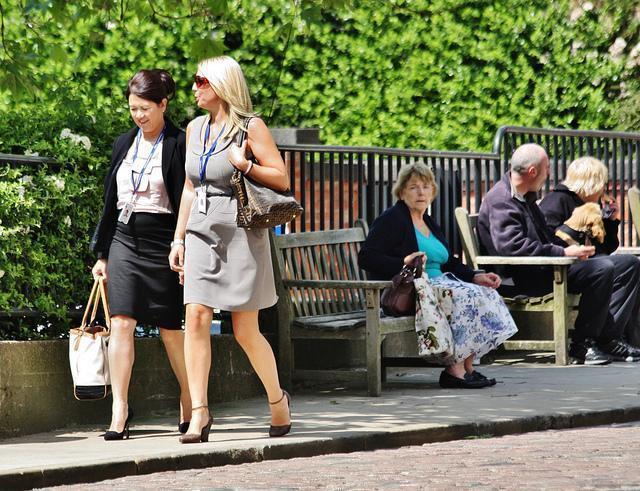Where are they likely to work from?
Indicate the correct response by choosing from the four available options to answer the question.
Options: Office, home, warehouse, constraction. Office. 